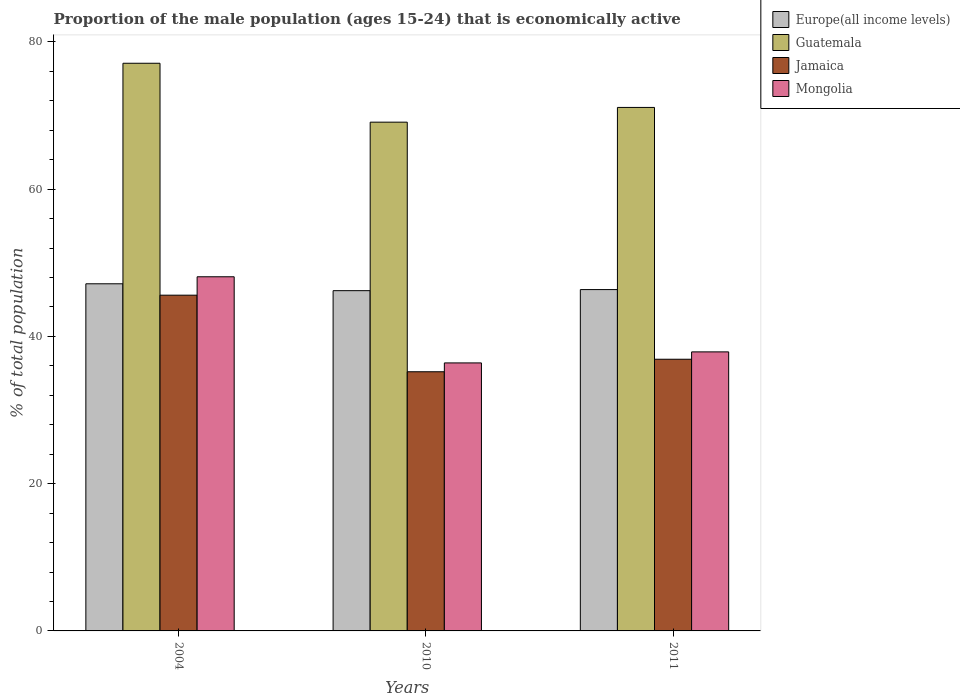How many groups of bars are there?
Offer a terse response. 3. How many bars are there on the 2nd tick from the left?
Provide a short and direct response. 4. How many bars are there on the 3rd tick from the right?
Provide a succinct answer. 4. What is the label of the 2nd group of bars from the left?
Offer a very short reply. 2010. In how many cases, is the number of bars for a given year not equal to the number of legend labels?
Ensure brevity in your answer.  0. What is the proportion of the male population that is economically active in Europe(all income levels) in 2010?
Keep it short and to the point. 46.21. Across all years, what is the maximum proportion of the male population that is economically active in Jamaica?
Give a very brief answer. 45.6. Across all years, what is the minimum proportion of the male population that is economically active in Jamaica?
Offer a very short reply. 35.2. In which year was the proportion of the male population that is economically active in Europe(all income levels) minimum?
Give a very brief answer. 2010. What is the total proportion of the male population that is economically active in Mongolia in the graph?
Keep it short and to the point. 122.4. What is the difference between the proportion of the male population that is economically active in Mongolia in 2010 and that in 2011?
Give a very brief answer. -1.5. What is the difference between the proportion of the male population that is economically active in Guatemala in 2010 and the proportion of the male population that is economically active in Europe(all income levels) in 2004?
Provide a short and direct response. 21.95. What is the average proportion of the male population that is economically active in Guatemala per year?
Keep it short and to the point. 72.43. In the year 2004, what is the difference between the proportion of the male population that is economically active in Mongolia and proportion of the male population that is economically active in Guatemala?
Make the answer very short. -29. What is the ratio of the proportion of the male population that is economically active in Mongolia in 2010 to that in 2011?
Make the answer very short. 0.96. Is the proportion of the male population that is economically active in Jamaica in 2010 less than that in 2011?
Ensure brevity in your answer.  Yes. What is the difference between the highest and the second highest proportion of the male population that is economically active in Europe(all income levels)?
Keep it short and to the point. 0.79. What is the difference between the highest and the lowest proportion of the male population that is economically active in Jamaica?
Provide a short and direct response. 10.4. In how many years, is the proportion of the male population that is economically active in Jamaica greater than the average proportion of the male population that is economically active in Jamaica taken over all years?
Offer a terse response. 1. Is the sum of the proportion of the male population that is economically active in Guatemala in 2004 and 2010 greater than the maximum proportion of the male population that is economically active in Mongolia across all years?
Provide a short and direct response. Yes. Is it the case that in every year, the sum of the proportion of the male population that is economically active in Mongolia and proportion of the male population that is economically active in Europe(all income levels) is greater than the sum of proportion of the male population that is economically active in Guatemala and proportion of the male population that is economically active in Jamaica?
Your response must be concise. No. What does the 2nd bar from the left in 2004 represents?
Give a very brief answer. Guatemala. What does the 3rd bar from the right in 2011 represents?
Offer a very short reply. Guatemala. Is it the case that in every year, the sum of the proportion of the male population that is economically active in Guatemala and proportion of the male population that is economically active in Jamaica is greater than the proportion of the male population that is economically active in Europe(all income levels)?
Keep it short and to the point. Yes. How many bars are there?
Make the answer very short. 12. Are all the bars in the graph horizontal?
Keep it short and to the point. No. What is the difference between two consecutive major ticks on the Y-axis?
Make the answer very short. 20. Are the values on the major ticks of Y-axis written in scientific E-notation?
Your answer should be very brief. No. Does the graph contain any zero values?
Your response must be concise. No. Does the graph contain grids?
Provide a short and direct response. No. Where does the legend appear in the graph?
Provide a succinct answer. Top right. How many legend labels are there?
Your response must be concise. 4. What is the title of the graph?
Provide a short and direct response. Proportion of the male population (ages 15-24) that is economically active. What is the label or title of the Y-axis?
Your response must be concise. % of total population. What is the % of total population in Europe(all income levels) in 2004?
Provide a succinct answer. 47.15. What is the % of total population of Guatemala in 2004?
Keep it short and to the point. 77.1. What is the % of total population in Jamaica in 2004?
Your answer should be compact. 45.6. What is the % of total population in Mongolia in 2004?
Make the answer very short. 48.1. What is the % of total population of Europe(all income levels) in 2010?
Your response must be concise. 46.21. What is the % of total population of Guatemala in 2010?
Ensure brevity in your answer.  69.1. What is the % of total population of Jamaica in 2010?
Ensure brevity in your answer.  35.2. What is the % of total population in Mongolia in 2010?
Your response must be concise. 36.4. What is the % of total population in Europe(all income levels) in 2011?
Your answer should be compact. 46.36. What is the % of total population of Guatemala in 2011?
Make the answer very short. 71.1. What is the % of total population in Jamaica in 2011?
Your answer should be compact. 36.9. What is the % of total population of Mongolia in 2011?
Provide a short and direct response. 37.9. Across all years, what is the maximum % of total population of Europe(all income levels)?
Keep it short and to the point. 47.15. Across all years, what is the maximum % of total population in Guatemala?
Keep it short and to the point. 77.1. Across all years, what is the maximum % of total population of Jamaica?
Ensure brevity in your answer.  45.6. Across all years, what is the maximum % of total population in Mongolia?
Your answer should be very brief. 48.1. Across all years, what is the minimum % of total population of Europe(all income levels)?
Make the answer very short. 46.21. Across all years, what is the minimum % of total population of Guatemala?
Your response must be concise. 69.1. Across all years, what is the minimum % of total population of Jamaica?
Your answer should be compact. 35.2. Across all years, what is the minimum % of total population in Mongolia?
Your answer should be very brief. 36.4. What is the total % of total population of Europe(all income levels) in the graph?
Your response must be concise. 139.72. What is the total % of total population in Guatemala in the graph?
Offer a very short reply. 217.3. What is the total % of total population in Jamaica in the graph?
Provide a short and direct response. 117.7. What is the total % of total population of Mongolia in the graph?
Give a very brief answer. 122.4. What is the difference between the % of total population of Europe(all income levels) in 2004 and that in 2010?
Offer a very short reply. 0.94. What is the difference between the % of total population of Guatemala in 2004 and that in 2010?
Keep it short and to the point. 8. What is the difference between the % of total population in Jamaica in 2004 and that in 2010?
Give a very brief answer. 10.4. What is the difference between the % of total population in Mongolia in 2004 and that in 2010?
Your response must be concise. 11.7. What is the difference between the % of total population in Europe(all income levels) in 2004 and that in 2011?
Offer a terse response. 0.79. What is the difference between the % of total population of Jamaica in 2004 and that in 2011?
Your answer should be very brief. 8.7. What is the difference between the % of total population in Mongolia in 2004 and that in 2011?
Provide a succinct answer. 10.2. What is the difference between the % of total population of Europe(all income levels) in 2010 and that in 2011?
Offer a very short reply. -0.15. What is the difference between the % of total population in Guatemala in 2010 and that in 2011?
Keep it short and to the point. -2. What is the difference between the % of total population in Jamaica in 2010 and that in 2011?
Give a very brief answer. -1.7. What is the difference between the % of total population of Mongolia in 2010 and that in 2011?
Provide a short and direct response. -1.5. What is the difference between the % of total population in Europe(all income levels) in 2004 and the % of total population in Guatemala in 2010?
Make the answer very short. -21.95. What is the difference between the % of total population of Europe(all income levels) in 2004 and the % of total population of Jamaica in 2010?
Make the answer very short. 11.95. What is the difference between the % of total population in Europe(all income levels) in 2004 and the % of total population in Mongolia in 2010?
Ensure brevity in your answer.  10.75. What is the difference between the % of total population of Guatemala in 2004 and the % of total population of Jamaica in 2010?
Your answer should be compact. 41.9. What is the difference between the % of total population in Guatemala in 2004 and the % of total population in Mongolia in 2010?
Ensure brevity in your answer.  40.7. What is the difference between the % of total population of Jamaica in 2004 and the % of total population of Mongolia in 2010?
Make the answer very short. 9.2. What is the difference between the % of total population in Europe(all income levels) in 2004 and the % of total population in Guatemala in 2011?
Your answer should be very brief. -23.95. What is the difference between the % of total population of Europe(all income levels) in 2004 and the % of total population of Jamaica in 2011?
Make the answer very short. 10.25. What is the difference between the % of total population of Europe(all income levels) in 2004 and the % of total population of Mongolia in 2011?
Provide a succinct answer. 9.25. What is the difference between the % of total population in Guatemala in 2004 and the % of total population in Jamaica in 2011?
Provide a short and direct response. 40.2. What is the difference between the % of total population of Guatemala in 2004 and the % of total population of Mongolia in 2011?
Give a very brief answer. 39.2. What is the difference between the % of total population of Europe(all income levels) in 2010 and the % of total population of Guatemala in 2011?
Your response must be concise. -24.89. What is the difference between the % of total population of Europe(all income levels) in 2010 and the % of total population of Jamaica in 2011?
Ensure brevity in your answer.  9.31. What is the difference between the % of total population in Europe(all income levels) in 2010 and the % of total population in Mongolia in 2011?
Your answer should be very brief. 8.31. What is the difference between the % of total population of Guatemala in 2010 and the % of total population of Jamaica in 2011?
Your response must be concise. 32.2. What is the difference between the % of total population in Guatemala in 2010 and the % of total population in Mongolia in 2011?
Offer a very short reply. 31.2. What is the average % of total population in Europe(all income levels) per year?
Provide a short and direct response. 46.57. What is the average % of total population in Guatemala per year?
Offer a very short reply. 72.43. What is the average % of total population in Jamaica per year?
Your answer should be very brief. 39.23. What is the average % of total population in Mongolia per year?
Your answer should be very brief. 40.8. In the year 2004, what is the difference between the % of total population in Europe(all income levels) and % of total population in Guatemala?
Make the answer very short. -29.95. In the year 2004, what is the difference between the % of total population in Europe(all income levels) and % of total population in Jamaica?
Ensure brevity in your answer.  1.55. In the year 2004, what is the difference between the % of total population of Europe(all income levels) and % of total population of Mongolia?
Give a very brief answer. -0.95. In the year 2004, what is the difference between the % of total population of Guatemala and % of total population of Jamaica?
Your answer should be compact. 31.5. In the year 2004, what is the difference between the % of total population in Guatemala and % of total population in Mongolia?
Provide a short and direct response. 29. In the year 2010, what is the difference between the % of total population of Europe(all income levels) and % of total population of Guatemala?
Ensure brevity in your answer.  -22.89. In the year 2010, what is the difference between the % of total population of Europe(all income levels) and % of total population of Jamaica?
Your answer should be compact. 11.01. In the year 2010, what is the difference between the % of total population in Europe(all income levels) and % of total population in Mongolia?
Offer a terse response. 9.81. In the year 2010, what is the difference between the % of total population in Guatemala and % of total population in Jamaica?
Make the answer very short. 33.9. In the year 2010, what is the difference between the % of total population of Guatemala and % of total population of Mongolia?
Make the answer very short. 32.7. In the year 2010, what is the difference between the % of total population of Jamaica and % of total population of Mongolia?
Your response must be concise. -1.2. In the year 2011, what is the difference between the % of total population of Europe(all income levels) and % of total population of Guatemala?
Offer a terse response. -24.74. In the year 2011, what is the difference between the % of total population in Europe(all income levels) and % of total population in Jamaica?
Your answer should be compact. 9.46. In the year 2011, what is the difference between the % of total population of Europe(all income levels) and % of total population of Mongolia?
Keep it short and to the point. 8.46. In the year 2011, what is the difference between the % of total population of Guatemala and % of total population of Jamaica?
Provide a short and direct response. 34.2. In the year 2011, what is the difference between the % of total population in Guatemala and % of total population in Mongolia?
Offer a terse response. 33.2. What is the ratio of the % of total population in Europe(all income levels) in 2004 to that in 2010?
Your answer should be compact. 1.02. What is the ratio of the % of total population in Guatemala in 2004 to that in 2010?
Your response must be concise. 1.12. What is the ratio of the % of total population in Jamaica in 2004 to that in 2010?
Keep it short and to the point. 1.3. What is the ratio of the % of total population of Mongolia in 2004 to that in 2010?
Provide a short and direct response. 1.32. What is the ratio of the % of total population in Europe(all income levels) in 2004 to that in 2011?
Offer a very short reply. 1.02. What is the ratio of the % of total population of Guatemala in 2004 to that in 2011?
Offer a very short reply. 1.08. What is the ratio of the % of total population of Jamaica in 2004 to that in 2011?
Ensure brevity in your answer.  1.24. What is the ratio of the % of total population of Mongolia in 2004 to that in 2011?
Your answer should be compact. 1.27. What is the ratio of the % of total population in Europe(all income levels) in 2010 to that in 2011?
Ensure brevity in your answer.  1. What is the ratio of the % of total population in Guatemala in 2010 to that in 2011?
Offer a very short reply. 0.97. What is the ratio of the % of total population in Jamaica in 2010 to that in 2011?
Keep it short and to the point. 0.95. What is the ratio of the % of total population in Mongolia in 2010 to that in 2011?
Offer a terse response. 0.96. What is the difference between the highest and the second highest % of total population in Europe(all income levels)?
Provide a succinct answer. 0.79. What is the difference between the highest and the second highest % of total population of Jamaica?
Offer a terse response. 8.7. What is the difference between the highest and the lowest % of total population of Europe(all income levels)?
Ensure brevity in your answer.  0.94. What is the difference between the highest and the lowest % of total population of Mongolia?
Ensure brevity in your answer.  11.7. 